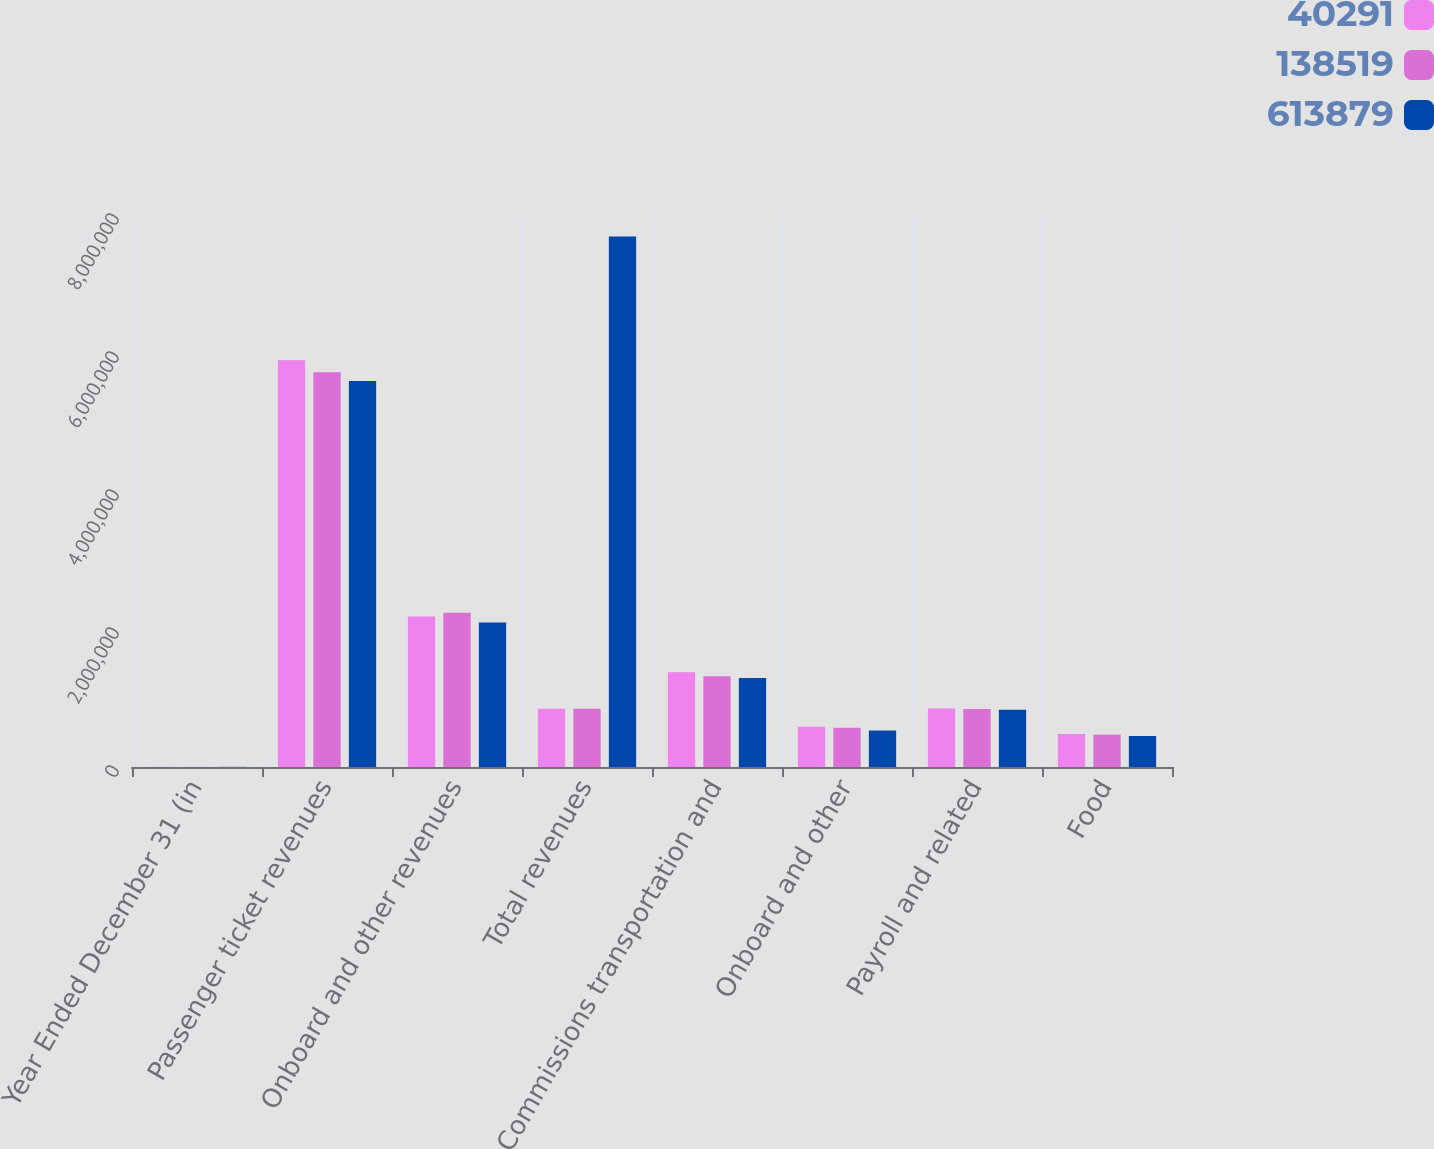Convert chart to OTSL. <chart><loc_0><loc_0><loc_500><loc_500><stacked_bar_chart><ecel><fcel>Year Ended December 31 (in<fcel>Passenger ticket revenues<fcel>Onboard and other revenues<fcel>Total revenues<fcel>Commissions transportation and<fcel>Onboard and other<fcel>Payroll and related<fcel>Food<nl><fcel>40291<fcel>2014<fcel>5.89385e+06<fcel>2.18001e+06<fcel>844689<fcel>1.37278e+06<fcel>582750<fcel>847641<fcel>478130<nl><fcel>138519<fcel>2013<fcel>5.72272e+06<fcel>2.23718e+06<fcel>844689<fcel>1.3146e+06<fcel>568615<fcel>841737<fcel>469653<nl><fcel>613879<fcel>2012<fcel>5.5946e+06<fcel>2.09343e+06<fcel>7.68802e+06<fcel>1.28926e+06<fcel>529453<fcel>828198<fcel>449649<nl></chart> 